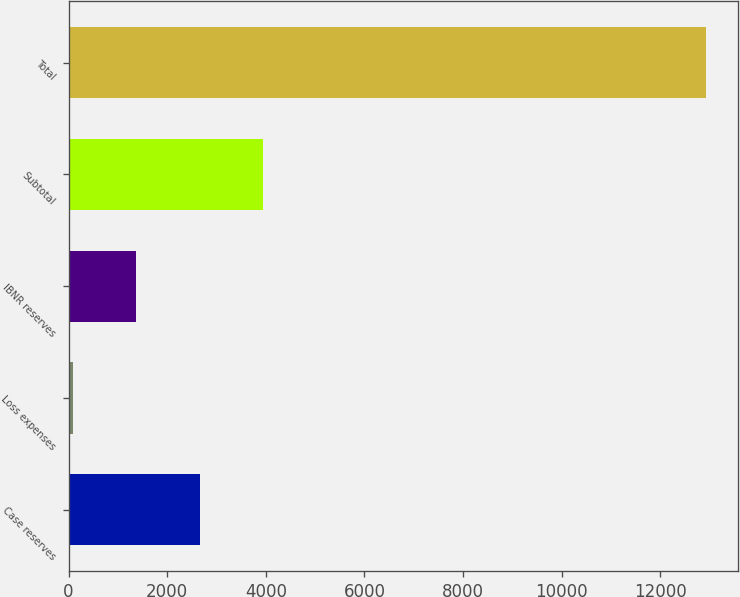<chart> <loc_0><loc_0><loc_500><loc_500><bar_chart><fcel>Case reserves<fcel>Loss expenses<fcel>IBNR reserves<fcel>Subtotal<fcel>Total<nl><fcel>2660.6<fcel>92<fcel>1376.3<fcel>3944.9<fcel>12935<nl></chart> 